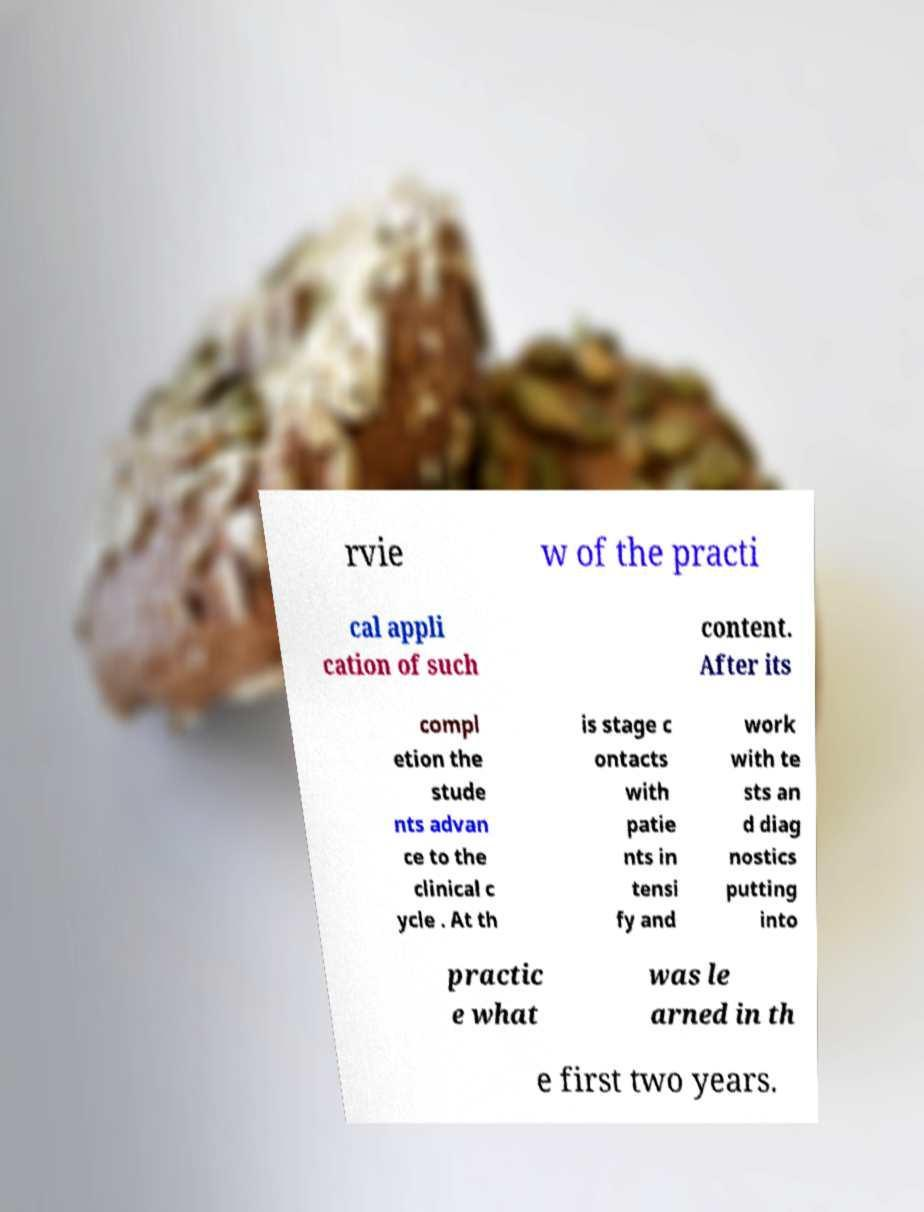Can you read and provide the text displayed in the image?This photo seems to have some interesting text. Can you extract and type it out for me? rvie w of the practi cal appli cation of such content. After its compl etion the stude nts advan ce to the clinical c ycle . At th is stage c ontacts with patie nts in tensi fy and work with te sts an d diag nostics putting into practic e what was le arned in th e first two years. 